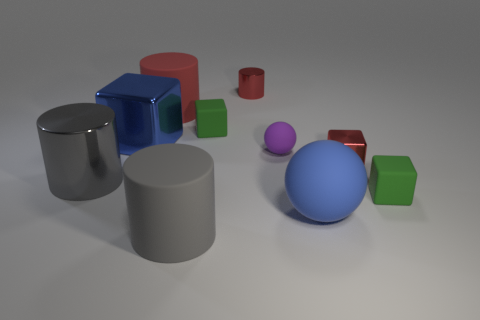Subtract all large gray matte cylinders. How many cylinders are left? 3 Subtract all green cubes. How many cubes are left? 2 Subtract all tiny blue metallic things. Subtract all big blue cubes. How many objects are left? 9 Add 5 small purple rubber things. How many small purple rubber things are left? 6 Add 7 blue things. How many blue things exist? 9 Subtract 1 red cubes. How many objects are left? 9 Subtract all spheres. How many objects are left? 8 Subtract 4 blocks. How many blocks are left? 0 Subtract all yellow blocks. Subtract all yellow spheres. How many blocks are left? 4 Subtract all gray cylinders. How many gray blocks are left? 0 